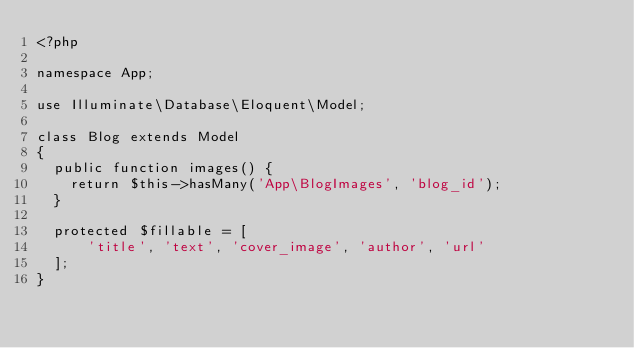Convert code to text. <code><loc_0><loc_0><loc_500><loc_500><_PHP_><?php

namespace App;

use Illuminate\Database\Eloquent\Model;

class Blog extends Model
{
  public function images() {
    return $this->hasMany('App\BlogImages', 'blog_id');
  }

  protected $fillable = [
      'title', 'text', 'cover_image', 'author', 'url'
  ];
}
</code> 